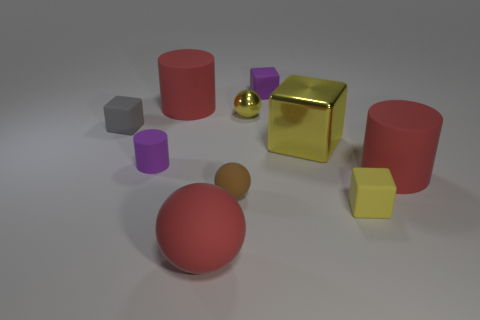Is the color of the metal cube the same as the metal sphere?
Give a very brief answer. Yes. How many other objects are the same material as the small yellow sphere?
Your answer should be very brief. 1. How many yellow objects are rubber cylinders or rubber objects?
Give a very brief answer. 1. There is a purple thing left of the small brown matte ball; is its shape the same as the red matte thing that is behind the tiny gray rubber object?
Provide a succinct answer. Yes. There is a large metallic object; is its color the same as the tiny thing that is in front of the brown thing?
Your answer should be compact. Yes. There is a small rubber block in front of the small gray thing; does it have the same color as the large ball?
Provide a succinct answer. No. How many objects are small gray matte balls or big matte objects behind the large red ball?
Ensure brevity in your answer.  2. What is the big object that is left of the small yellow cube and to the right of the brown thing made of?
Offer a very short reply. Metal. There is a red object that is behind the gray object; what material is it?
Offer a terse response. Rubber. The large sphere that is made of the same material as the small gray object is what color?
Keep it short and to the point. Red. 